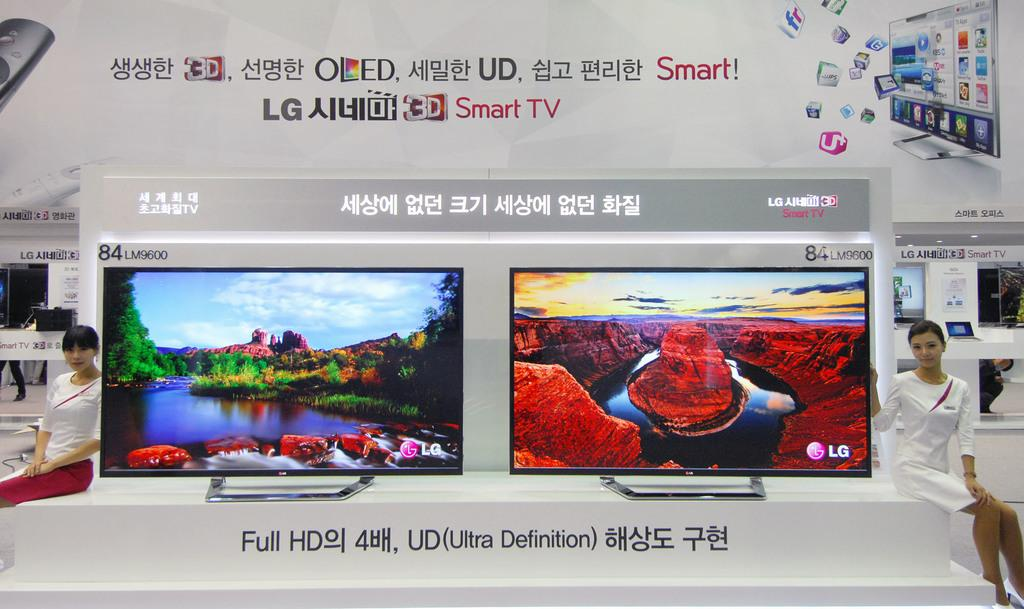Provide a one-sentence caption for the provided image. An ad with Asian writing features Smart TVs. 